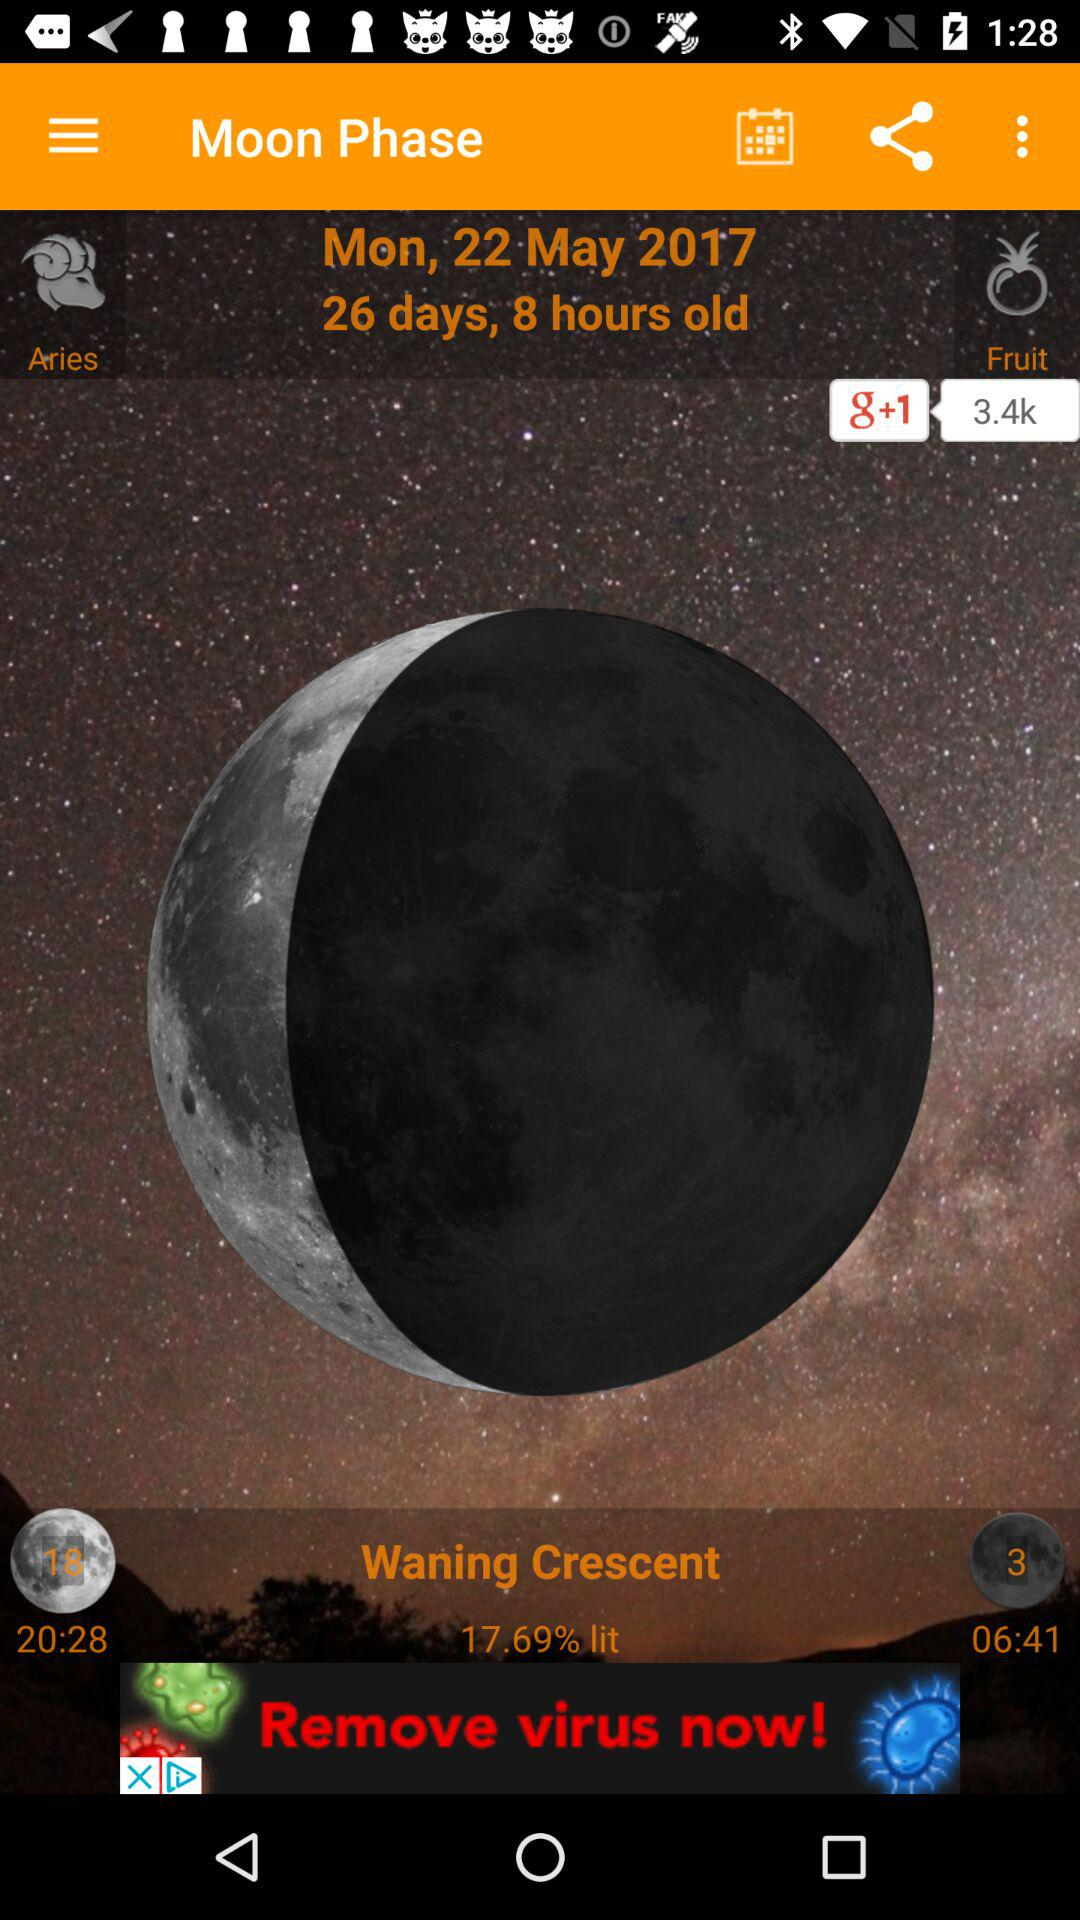What is the date of the moon phase? The date of the moon phase is Monday, May 22, 2017. 